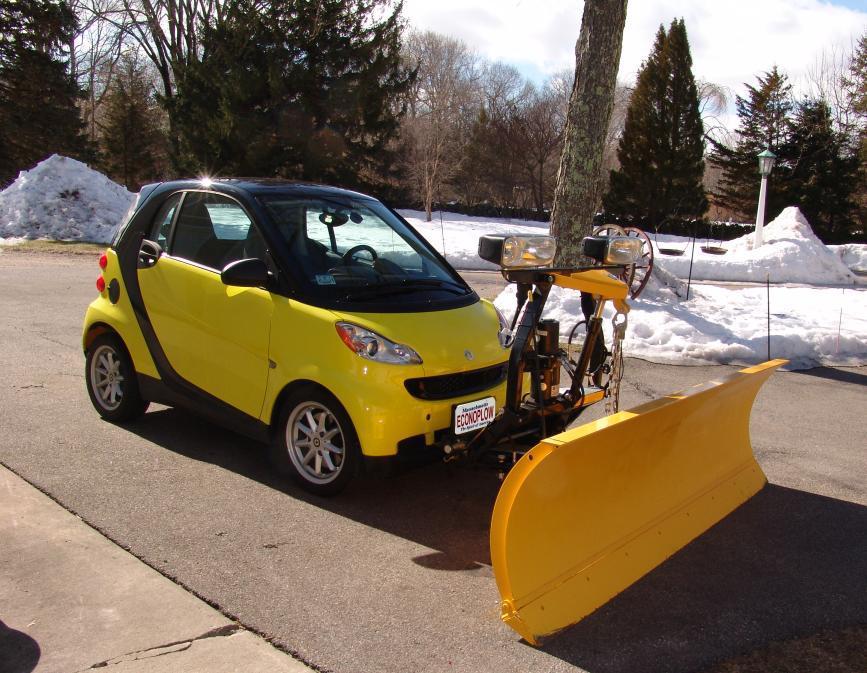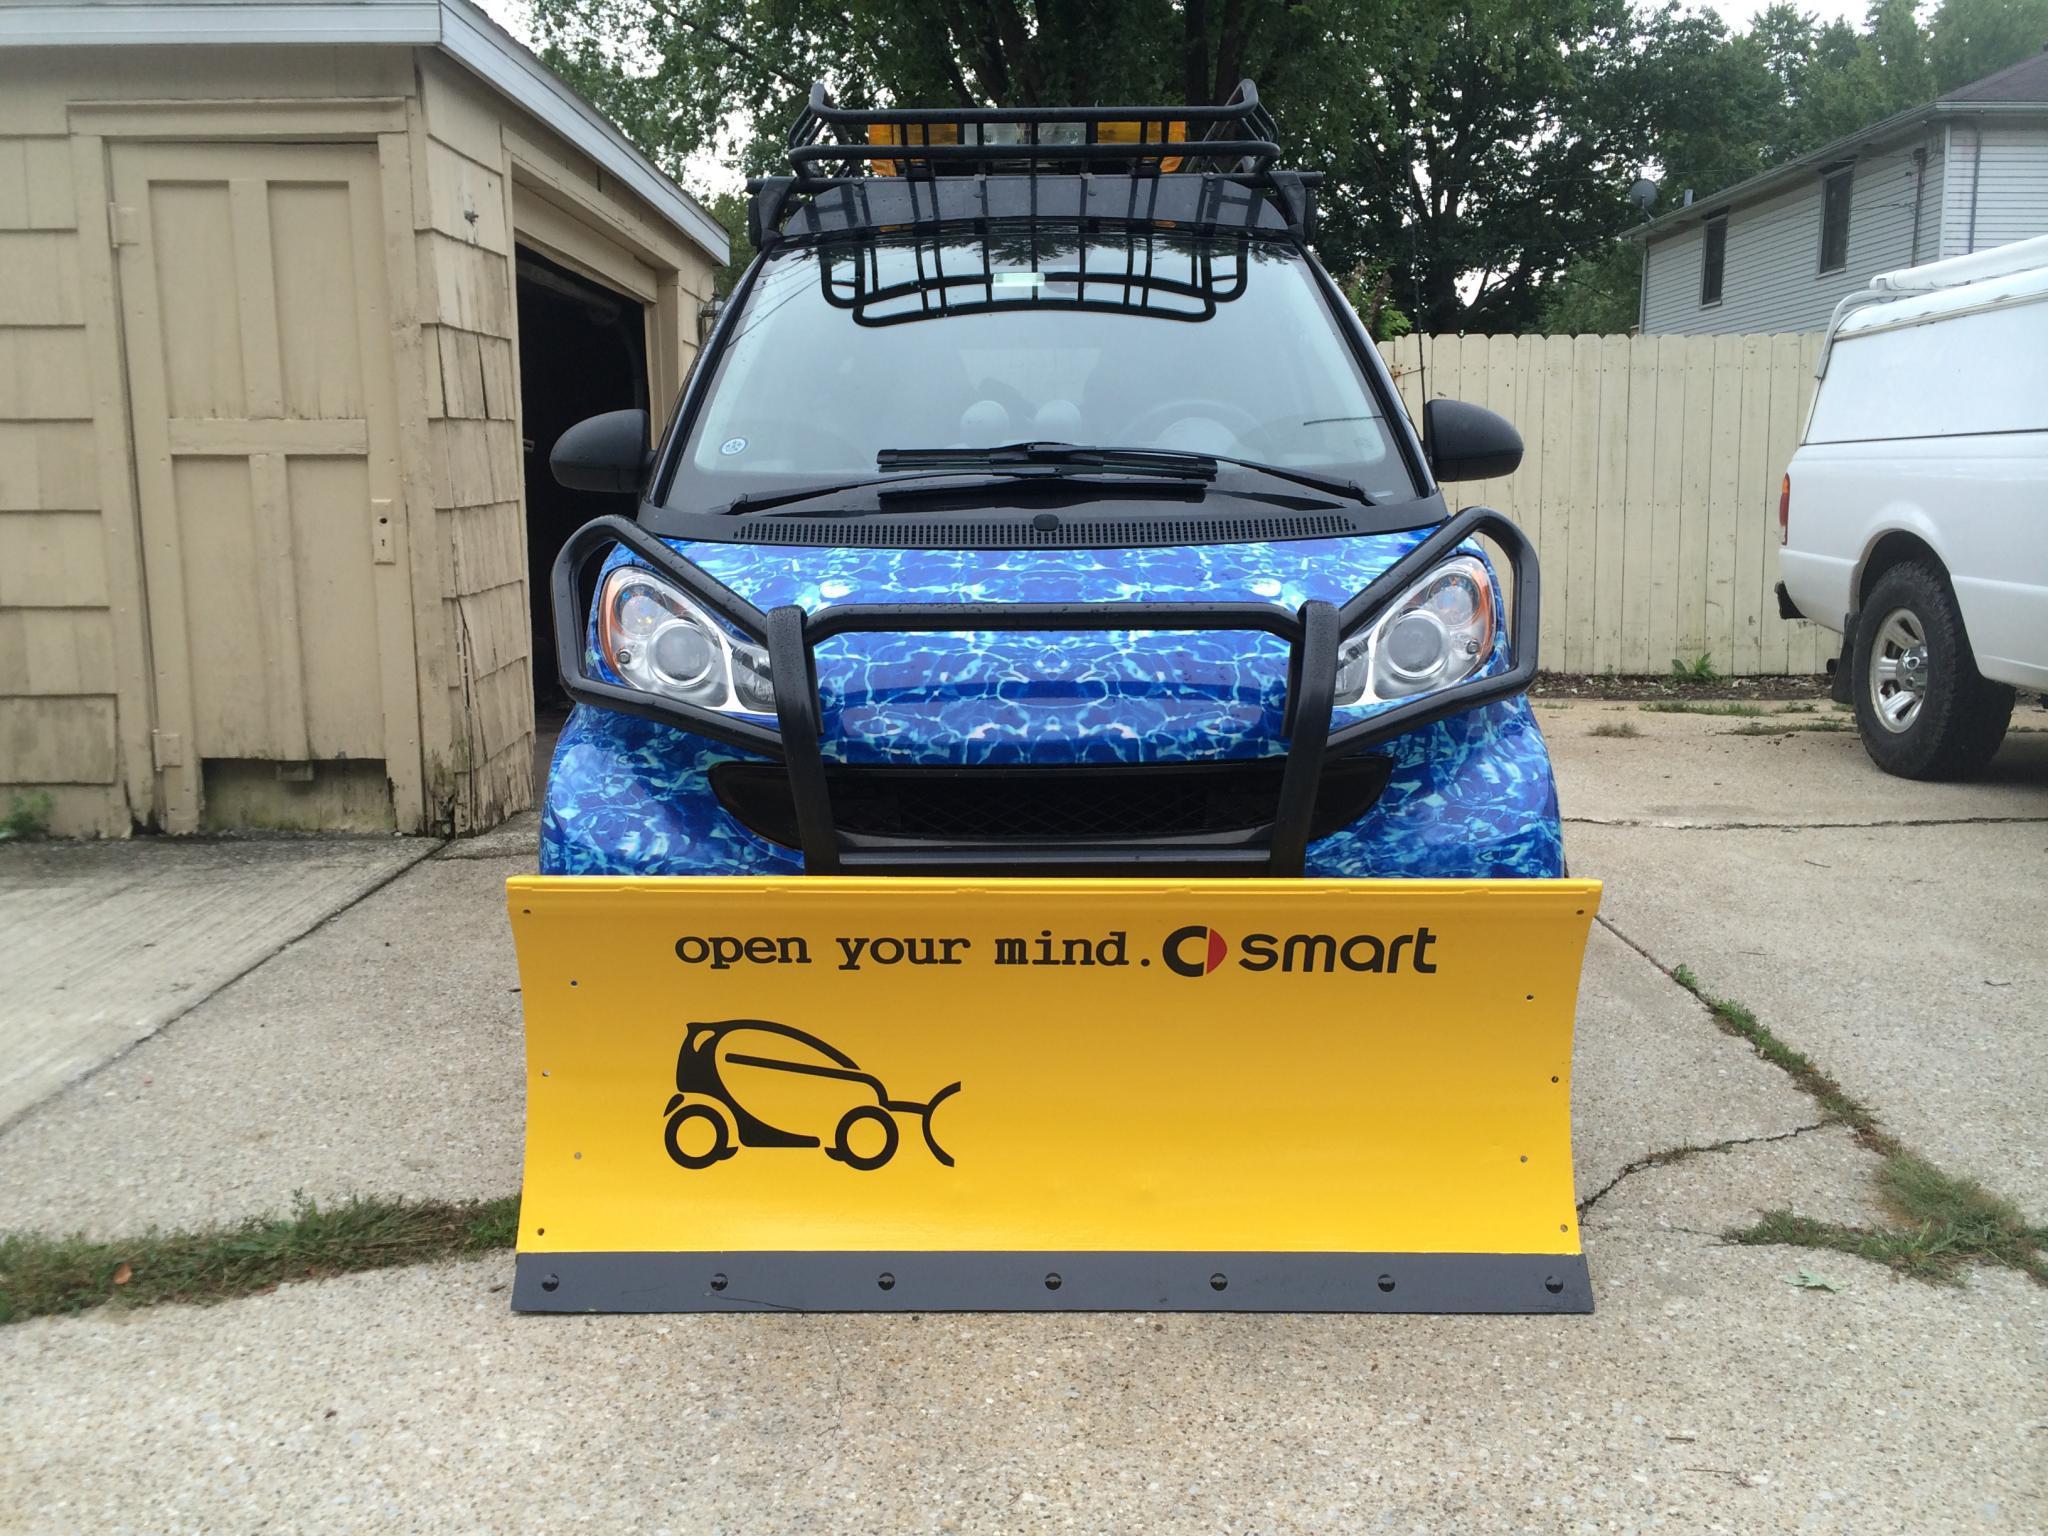The first image is the image on the left, the second image is the image on the right. For the images displayed, is the sentence "An image shows a smart-car shaped orange vehicle with a plow attachment." factually correct? Answer yes or no. No. The first image is the image on the left, the second image is the image on the right. For the images shown, is this caption "there is a yellow smart car with a plow blade on the front" true? Answer yes or no. Yes. 